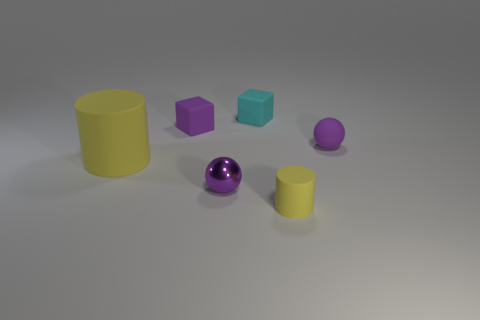Add 3 yellow metallic objects. How many objects exist? 9 Subtract 0 yellow spheres. How many objects are left? 6 Subtract all blocks. How many objects are left? 4 Subtract all tiny brown objects. Subtract all yellow objects. How many objects are left? 4 Add 6 tiny yellow matte things. How many tiny yellow matte things are left? 7 Add 5 small objects. How many small objects exist? 10 